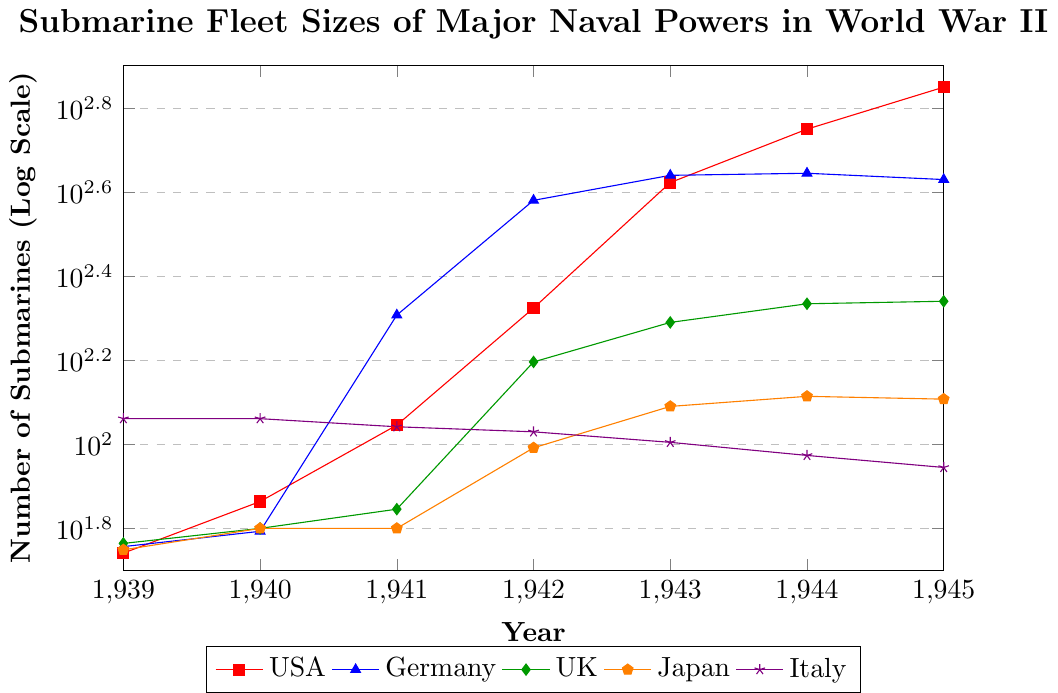Which country had the highest number of submarines in 1942? In 1942, the data shows that Germany had 381 submarines, which is the highest among the countries listed.
Answer: Germany How did the number of submarines of the USA and Germany compare in 1941? In 1941, the USA had 111 submarines while Germany had 203. Comparing these values, Germany had more submarines than the USA.
Answer: Germany had more From 1939 to 1945, which country saw the largest increase in submarine fleet size? Comparing the number of submarines in 1939 and 1945 for each country, the USA saw the largest increase from 55 submarines in 1939 to 709 submarines in 1945, an increase of 654.
Answer: USA In what year did Japan's submarine fleet size surpass 100? Observing Japan's submarine numbers across the years, Japan's fleet size surpassed 100 in the year 1943.
Answer: 1943 How many submarines did the UK have in 1940 and 1945, and what is the percentage increase? The UK had 63 submarines in 1940 and 219 in 1945. The percentage increase is given by ((219 - 63) / 63) * 100 = 247.62%.
Answer: 247.62% Which country had the least fluctuating number of submarines from 1939 to 1945? Based on the data, Italy's submarine fleet fluctuated the least, decreasing only from 115 to 88 from 1939 to 1945.
Answer: Italy In what year did Germany achieve its peak submarine fleet size, and what was that size? The peak fleet size for Germany was observed in 1943, with 437 submarines.
Answer: 1943 How did the submarine fleet sizes of Italy and the UK compare in 1939 and in 1944? In 1939, Italy had 115 submarines and the UK had 58. In 1944, Italy had 94 submarines and the UK had 216. Over this period, the UK's fleet size surpassed Italy's fleet size.
Answer: UK's fleet surpassed Italy's Which country experienced the steepest decline in submarine fleet size towards the end of the war (from 1944 to 1945)? Germany experienced the steepest decline in submarine fleet size, decreasing from 442 in 1944 to 427 in 1945.
Answer: Germany How many submarines did the major powers have in total in 1945, and does the USA contribute to the majority? The total number of submarines for all major powers in 1945 is 709 (USA) + 427 (Germany) + 219 (UK) + 128 (Japan) + 88 (Italy) = 1571. The USA contributes 709, which is roughly 45% of the total, making it the majority contributor.
Answer: Yes 